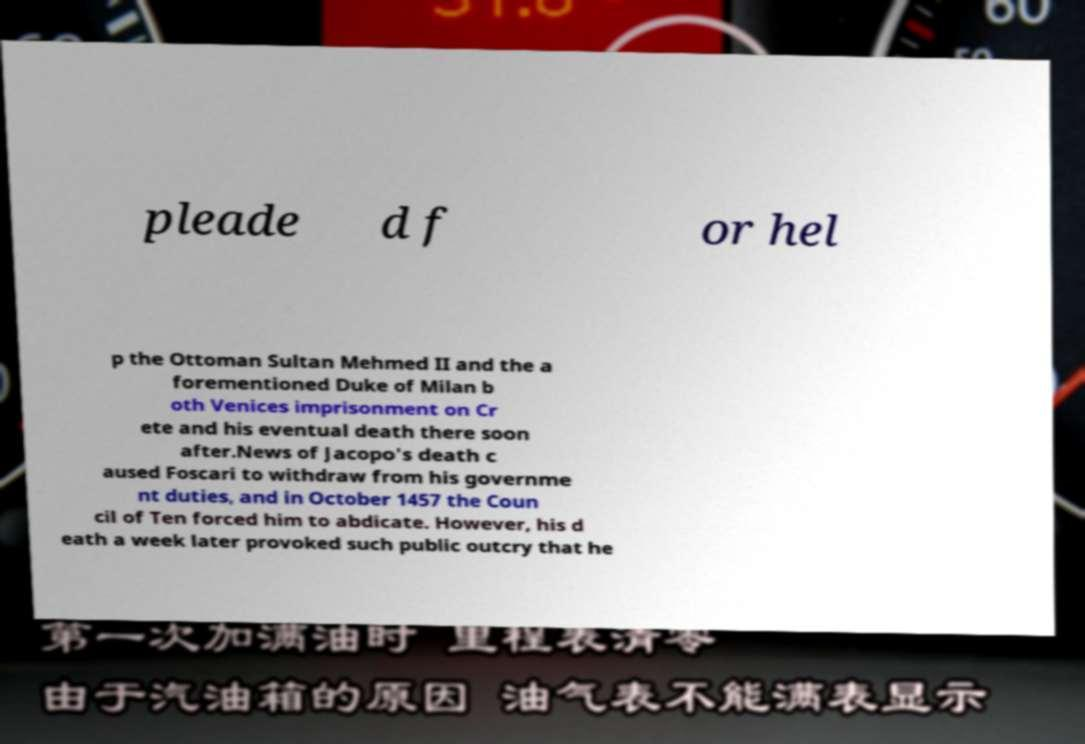Could you extract and type out the text from this image? pleade d f or hel p the Ottoman Sultan Mehmed II and the a forementioned Duke of Milan b oth Venices imprisonment on Cr ete and his eventual death there soon after.News of Jacopo's death c aused Foscari to withdraw from his governme nt duties, and in October 1457 the Coun cil of Ten forced him to abdicate. However, his d eath a week later provoked such public outcry that he 